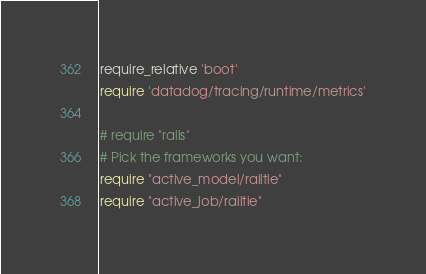<code> <loc_0><loc_0><loc_500><loc_500><_Ruby_>require_relative 'boot'
require 'datadog/tracing/runtime/metrics'

# require "rails"
# Pick the frameworks you want:
require "active_model/railtie"
require "active_job/railtie"</code> 